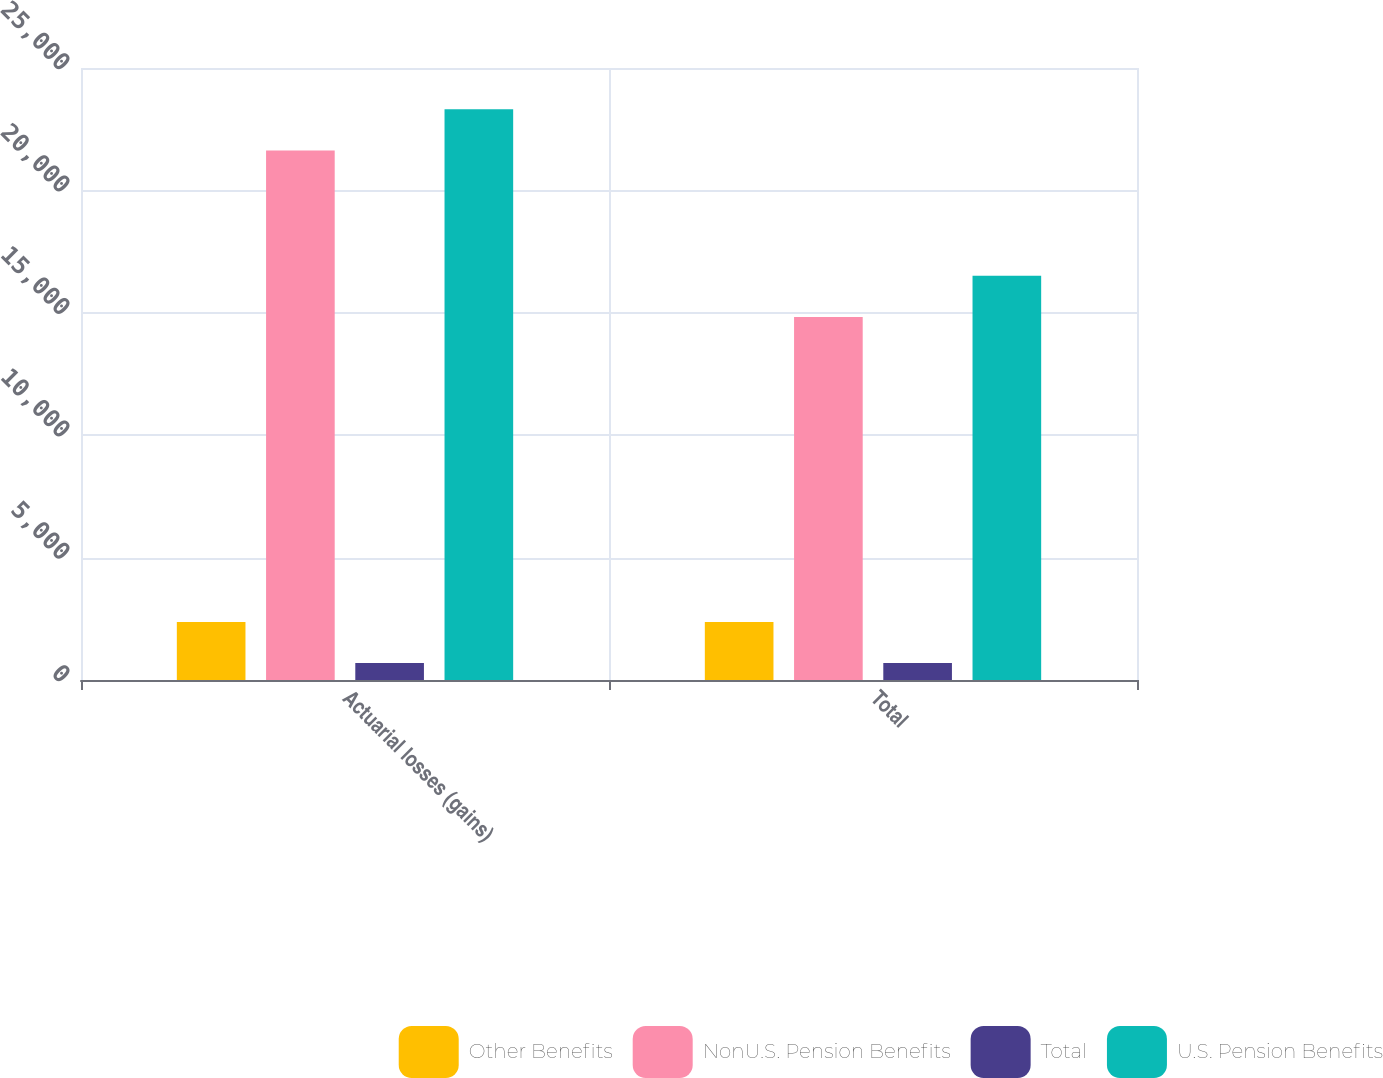<chart> <loc_0><loc_0><loc_500><loc_500><stacked_bar_chart><ecel><fcel>Actuarial losses (gains)<fcel>Total<nl><fcel>Other Benefits<fcel>2374<fcel>2374<nl><fcel>NonU.S. Pension Benefits<fcel>21630<fcel>14832<nl><fcel>Total<fcel>691<fcel>691<nl><fcel>U.S. Pension Benefits<fcel>23313<fcel>16515<nl></chart> 